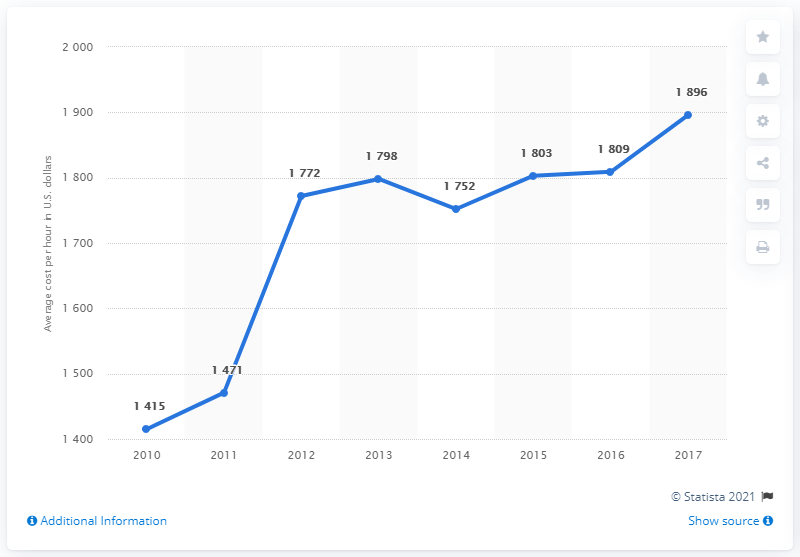Specify some key components in this picture. From 2010 to 2017, there was an increase of 481 points. L&D has been unavailable to employees since 2010. What was the value for 2013? It was 1,798. 